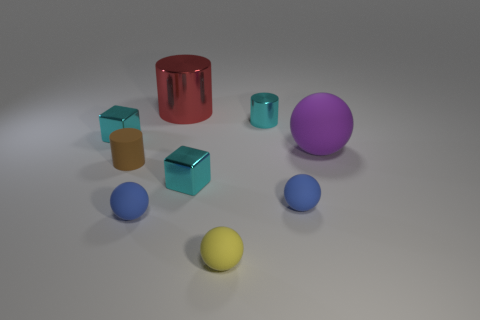Subtract all big red metal cylinders. How many cylinders are left? 2 Subtract all red cylinders. How many cylinders are left? 2 Subtract all cubes. How many objects are left? 7 Subtract 2 cylinders. How many cylinders are left? 1 Add 8 small blue objects. How many small blue objects exist? 10 Add 1 tiny blue objects. How many objects exist? 10 Subtract 0 red blocks. How many objects are left? 9 Subtract all red balls. Subtract all brown cubes. How many balls are left? 4 Subtract all purple balls. How many yellow cubes are left? 0 Subtract all big blue metal cylinders. Subtract all blue spheres. How many objects are left? 7 